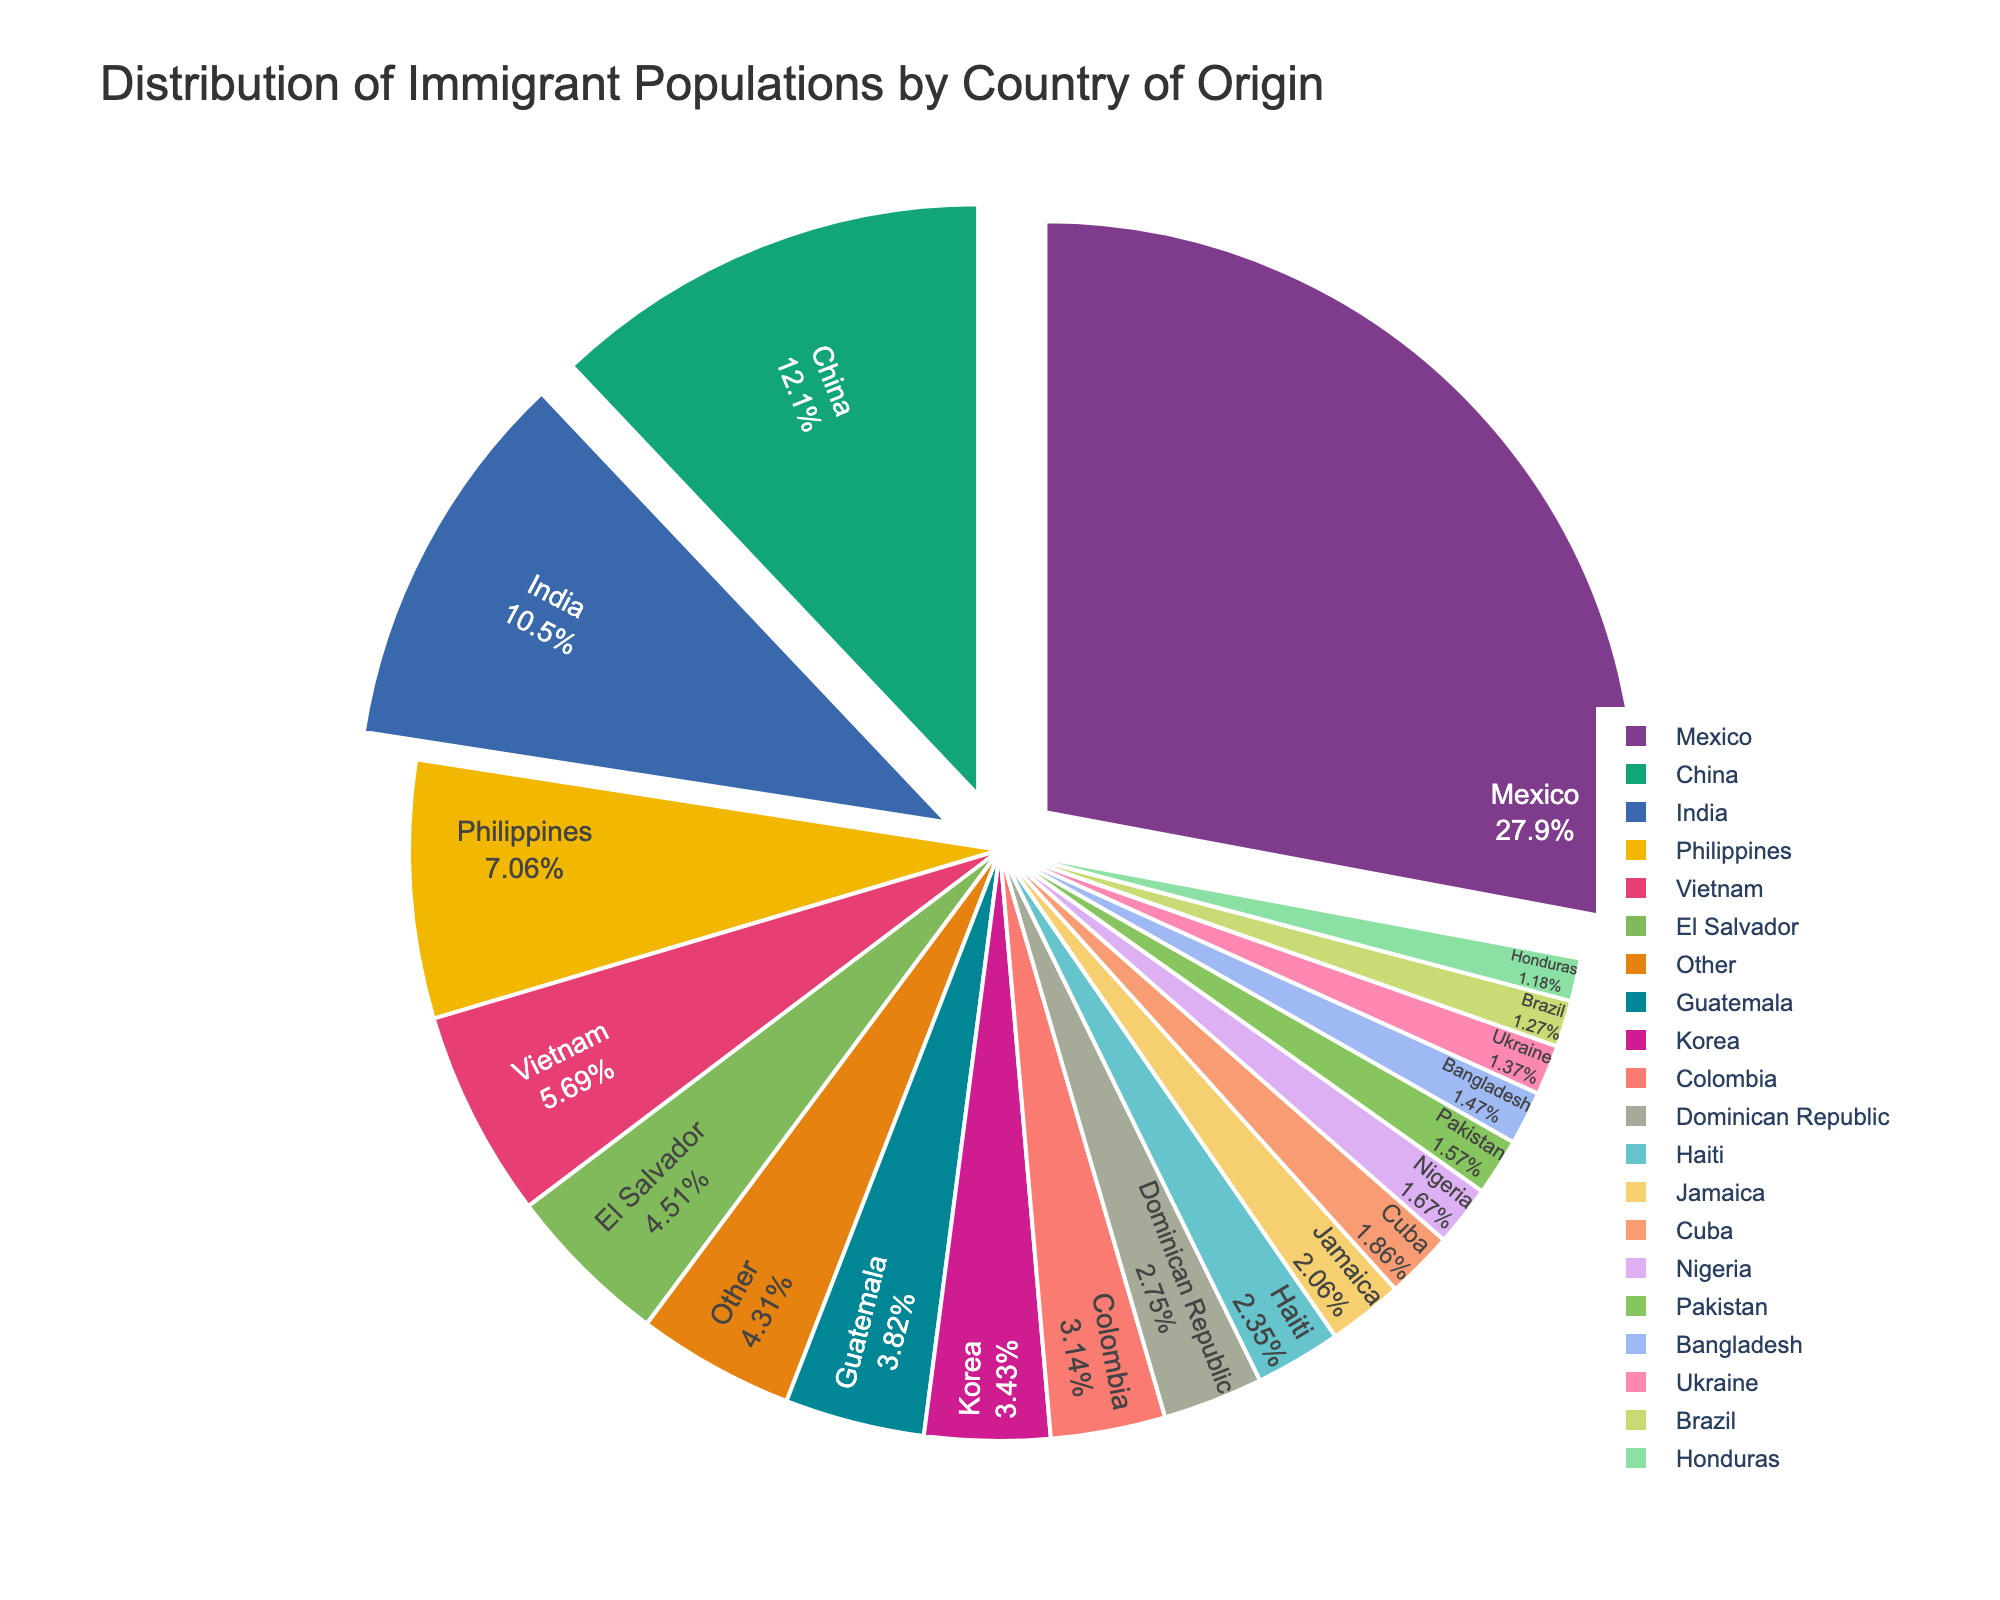Which country of origin has the highest percentage of the immigrant population? The figure shows the slices of the pie chart, and the largest slice represents Mexico. The percentage value next to Mexico confirms it.
Answer: Mexico What is the combined percentage of immigrant populations for China and India? To find the combined percentage, add the percentages for China (12.3%) and India (10.7%). 12.3 + 10.7 equals 23.
Answer: 23% Which three countries contribute the smallest percentages of the immigrant population, and what are their combined percentage values? The smallest slices on the pie chart with the lowest percentages are Bangladesh (1.5%), Ukraine (1.4%), and Brazil (1.3%). The combined value is calculated by summing these percentages. 1.5 + 1.4 + 1.3 equals 4.2.
Answer: Bangladesh, Ukraine, Brazil, 4.2% How much larger is the immigrant population from Mexico compared to the population from the Philippines? Subtract the percentage of immigrants from the Philippines (7.2%) from the percentage of immigrants from Mexico (28.5%). 28.5 - 7.2 equals 21.3.
Answer: 21.3% Which countries of origin account for a combined immigrant population of less than 5% each? Countries with individual percentage values each less than 5% are El Salvador (4.6%), Guatemala (3.9%), Korea (3.5%), Colombia (3.2%), Dominican Republic (2.8%), Haiti (2.4%), Jamaica (2.1%), Cuba (1.9%), Nigeria (1.7%), Pakistan (1.6%), Bangladesh (1.5%), Ukraine (1.4%), Brazil (1.3%), and Honduras (1.2%).
Answer: El Salvador, Guatemala, Korea, Colombia, Dominican Republic, Haiti, Jamaica, Cuba, Nigeria, Pakistan, Bangladesh, Ukraine, Brazil, Honduras What percentage of the immigrant population does the "Other" category represent, and how does it compare to the percentage for El Salvador? The "Other" category represents 4.4%. Comparing it with El Salvador’s 4.6%, the "Other" category has a lower percentage by 0.2.
Answer: 4.4%, lower by 0.2% Does any single country's immigrant population contribute more than 25%? If yes, which country is it? The pie chart shows that Mexico has a percentage value of 28.5%, which is more than 25%.
Answer: Yes, Mexico 